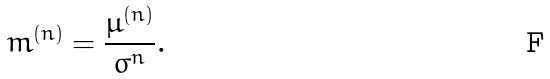Convert formula to latex. <formula><loc_0><loc_0><loc_500><loc_500>m ^ { ( n ) } = \frac { \mu ^ { ( n ) } } { \sigma ^ { n } } .</formula> 